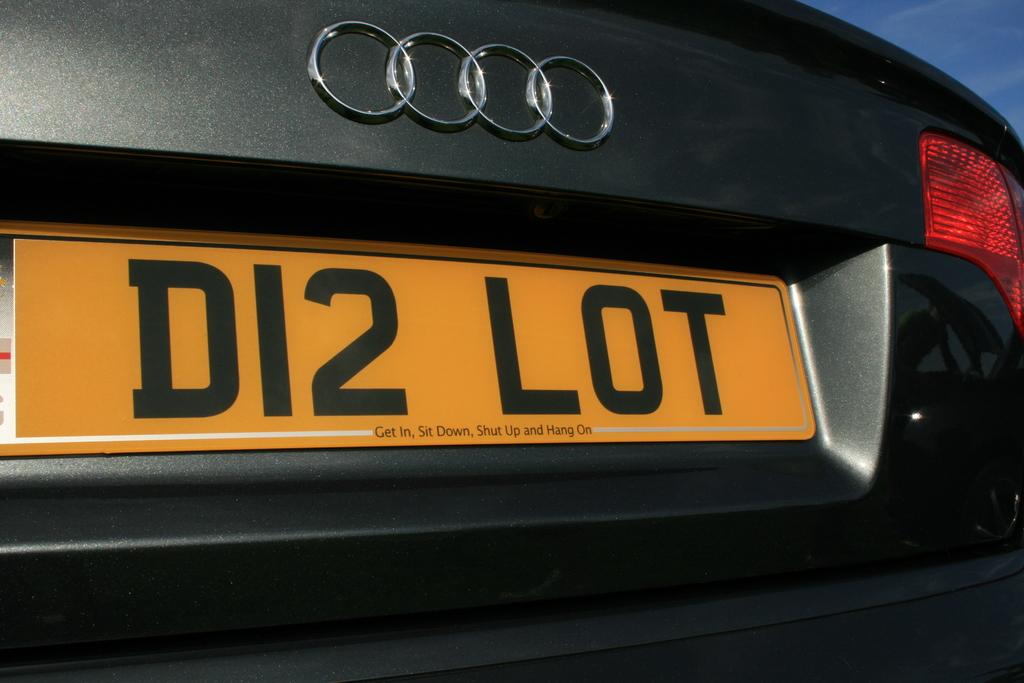What is written under the license plate number?
Make the answer very short. Get in, sit down, shut up and hang on. 